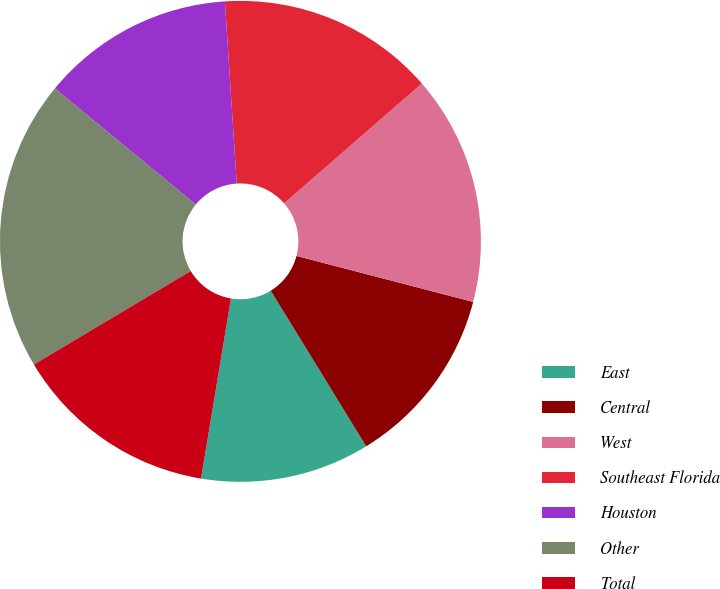Convert chart to OTSL. <chart><loc_0><loc_0><loc_500><loc_500><pie_chart><fcel>East<fcel>Central<fcel>West<fcel>Southeast Florida<fcel>Houston<fcel>Other<fcel>Total<nl><fcel>11.38%<fcel>12.19%<fcel>15.45%<fcel>14.63%<fcel>13.01%<fcel>19.52%<fcel>13.82%<nl></chart> 